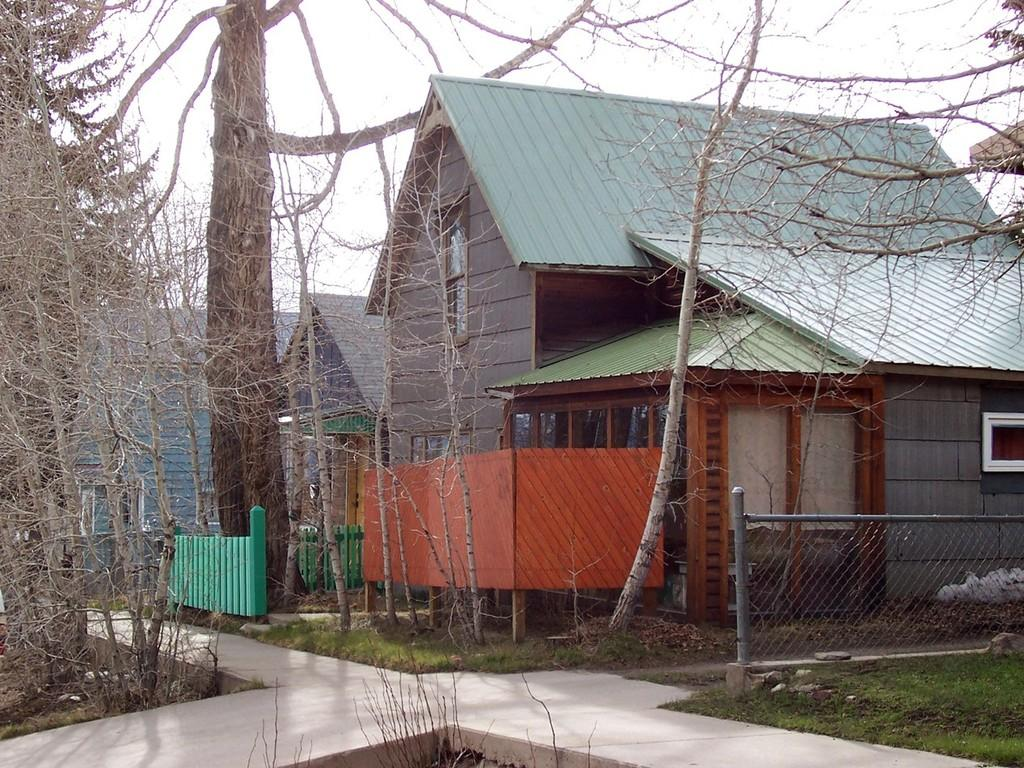What type of windows are on the houses in the image? The houses in the image have glass windows. What material is visible in the image that resembles a net or grid? Mesh is visible in the image. What structures are present in the image that resemble long, thin supports? Poles are present in the image. What type of vegetation is visible in the image? Grass is visible in the image. What type of pathway is present in the image? There is a walkway in the image. What type of plants are present in the image? Trees are present in the image. What type of barrier is visible in the image? Fencing is visible in the image. What is visible at the top of the image? The sky is visible at the top of the image. How does the authority figure in the image fold their mask? There is no authority figure or mask present in the image. What type of folding technique is used by the trees in the image? Trees do not fold, and there are no folding techniques involved in the image. 